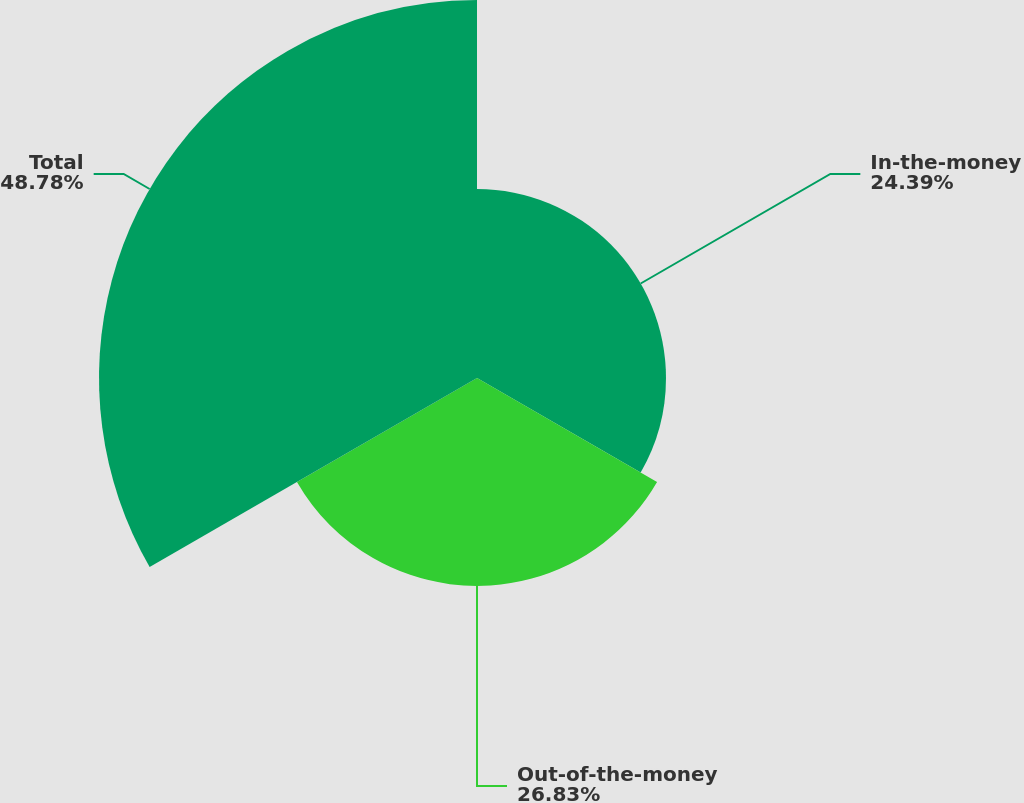Convert chart to OTSL. <chart><loc_0><loc_0><loc_500><loc_500><pie_chart><fcel>In-the-money<fcel>Out-of-the-money<fcel>Total<nl><fcel>24.39%<fcel>26.83%<fcel>48.78%<nl></chart> 